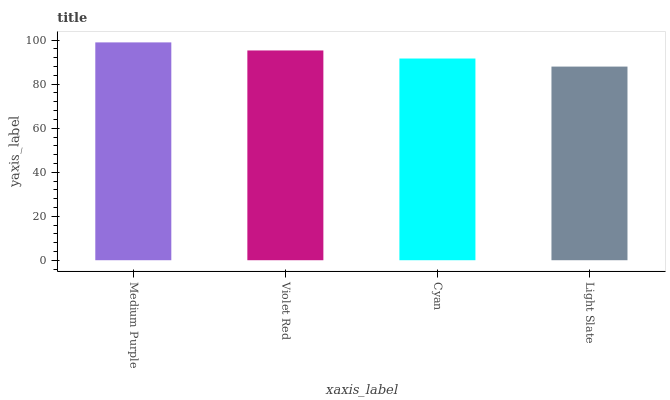Is Light Slate the minimum?
Answer yes or no. Yes. Is Medium Purple the maximum?
Answer yes or no. Yes. Is Violet Red the minimum?
Answer yes or no. No. Is Violet Red the maximum?
Answer yes or no. No. Is Medium Purple greater than Violet Red?
Answer yes or no. Yes. Is Violet Red less than Medium Purple?
Answer yes or no. Yes. Is Violet Red greater than Medium Purple?
Answer yes or no. No. Is Medium Purple less than Violet Red?
Answer yes or no. No. Is Violet Red the high median?
Answer yes or no. Yes. Is Cyan the low median?
Answer yes or no. Yes. Is Medium Purple the high median?
Answer yes or no. No. Is Medium Purple the low median?
Answer yes or no. No. 